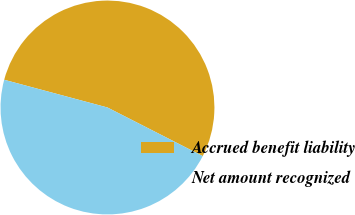Convert chart. <chart><loc_0><loc_0><loc_500><loc_500><pie_chart><fcel>Accrued benefit liability<fcel>Net amount recognized<nl><fcel>53.33%<fcel>46.67%<nl></chart> 